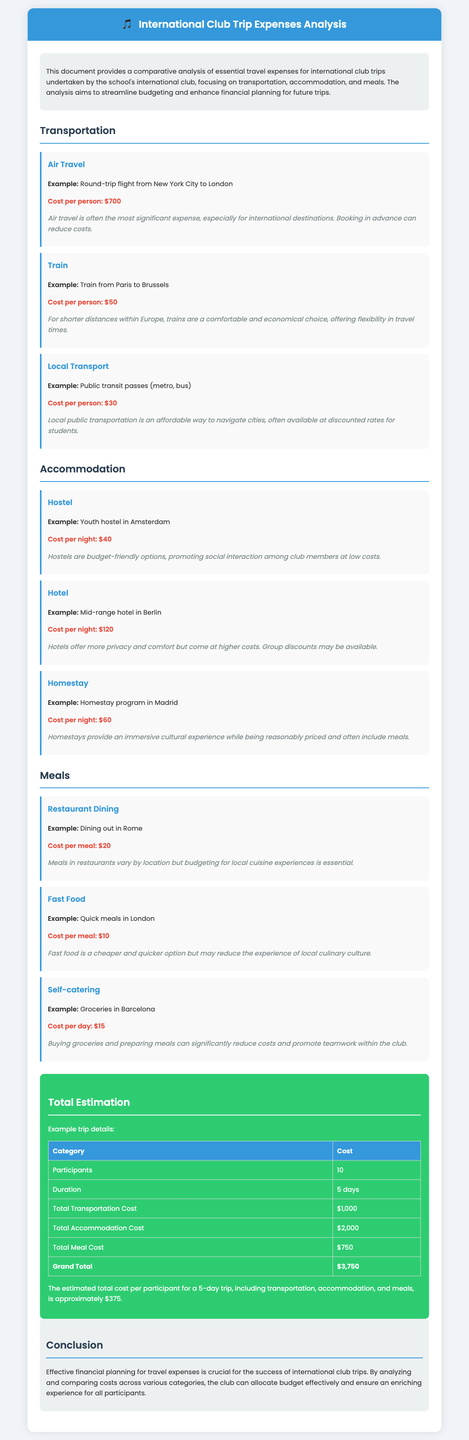What is the cost per person for air travel? The document states that the cost per person for air travel is $700.
Answer: $700 What is the cost per night for a hostel? According to the document, the cost per night for a hostel is $40.
Answer: $40 How much is the total meal cost for 10 participants? The total meal cost mentioned for 10 participants over the trip duration is $750.
Answer: $750 What is the grand total for the estimated trip expenses? The grand total for the estimated trip expenses is stated as $3,750.
Answer: $3,750 What is the cost per day for self-catering? The cost per day for self-catering is noted to be $15.
Answer: $15 What type of accommodations promote social interaction? The document mentions that hostels are budget-friendly options that promote social interaction.
Answer: Hostels How many days is the trip planned for? The report details that the trip is planned for 5 days.
Answer: 5 days What is the total transportation cost? The total transportation cost for the trip is listed as $1,000.
Answer: $1,000 What cuisine experience is mentioned in relation to restaurant dining? The document notes that budgeting for local cuisine experiences is essential.
Answer: Local cuisine 